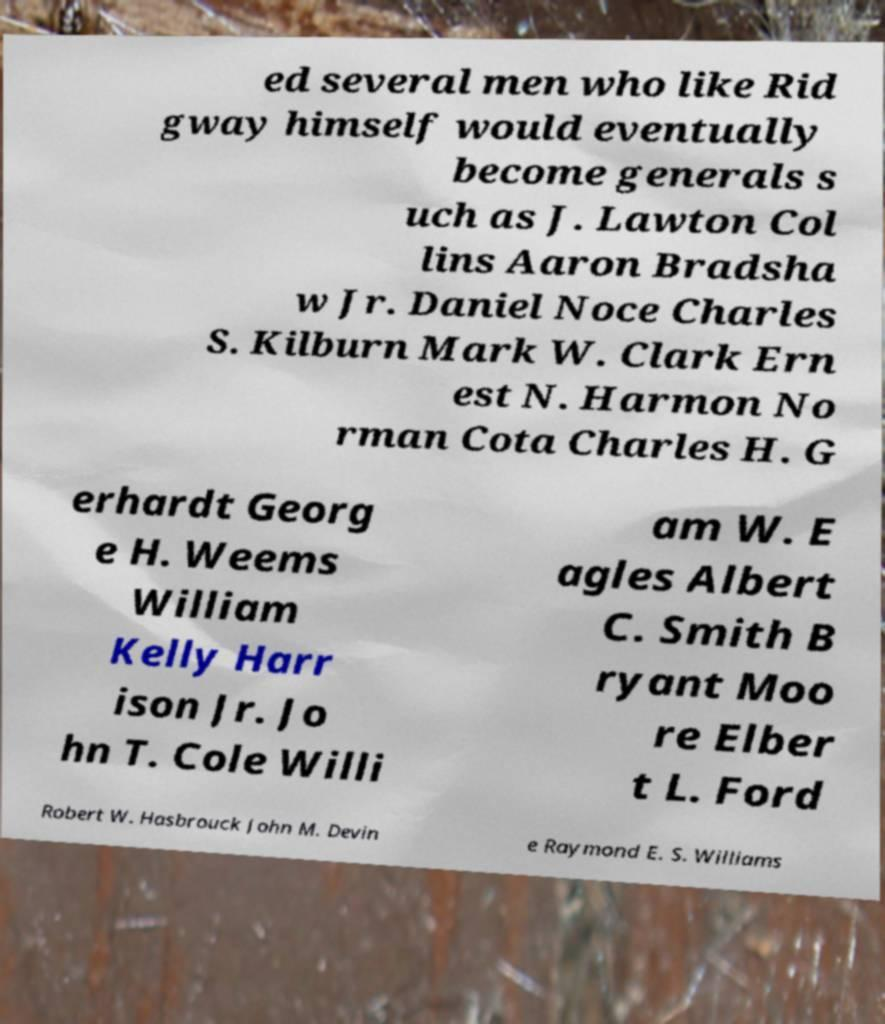There's text embedded in this image that I need extracted. Can you transcribe it verbatim? ed several men who like Rid gway himself would eventually become generals s uch as J. Lawton Col lins Aaron Bradsha w Jr. Daniel Noce Charles S. Kilburn Mark W. Clark Ern est N. Harmon No rman Cota Charles H. G erhardt Georg e H. Weems William Kelly Harr ison Jr. Jo hn T. Cole Willi am W. E agles Albert C. Smith B ryant Moo re Elber t L. Ford Robert W. Hasbrouck John M. Devin e Raymond E. S. Williams 